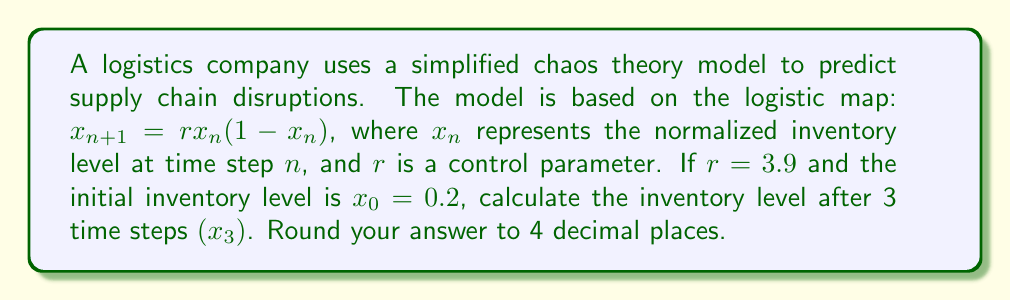Solve this math problem. To solve this problem, we need to iterate the logistic map equation three times:

Step 1: Calculate $x_1$
$$x_1 = r \cdot x_0 \cdot (1-x_0)$$
$$x_1 = 3.9 \cdot 0.2 \cdot (1-0.2)$$
$$x_1 = 3.9 \cdot 0.2 \cdot 0.8 = 0.624$$

Step 2: Calculate $x_2$
$$x_2 = r \cdot x_1 \cdot (1-x_1)$$
$$x_2 = 3.9 \cdot 0.624 \cdot (1-0.624)$$
$$x_2 = 3.9 \cdot 0.624 \cdot 0.376 = 0.9161664$$

Step 3: Calculate $x_3$
$$x_3 = r \cdot x_2 \cdot (1-x_2)$$
$$x_3 = 3.9 \cdot 0.9161664 \cdot (1-0.9161664)$$
$$x_3 = 3.9 \cdot 0.9161664 \cdot 0.0838336 = 0.2990$$

Step 4: Round to 4 decimal places
$$x_3 \approx 0.2990$$
Answer: 0.2990 